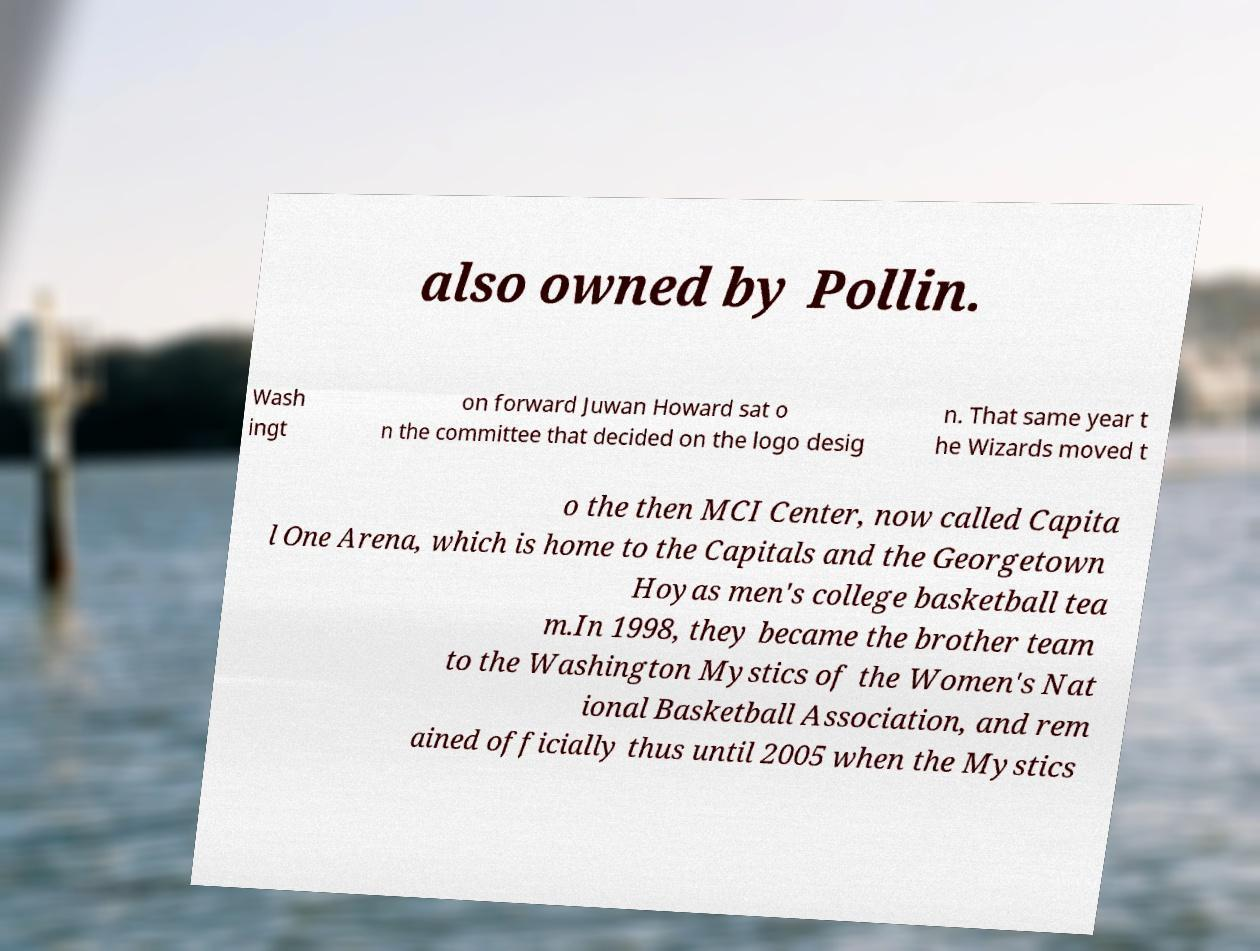Please read and relay the text visible in this image. What does it say? also owned by Pollin. Wash ingt on forward Juwan Howard sat o n the committee that decided on the logo desig n. That same year t he Wizards moved t o the then MCI Center, now called Capita l One Arena, which is home to the Capitals and the Georgetown Hoyas men's college basketball tea m.In 1998, they became the brother team to the Washington Mystics of the Women's Nat ional Basketball Association, and rem ained officially thus until 2005 when the Mystics 